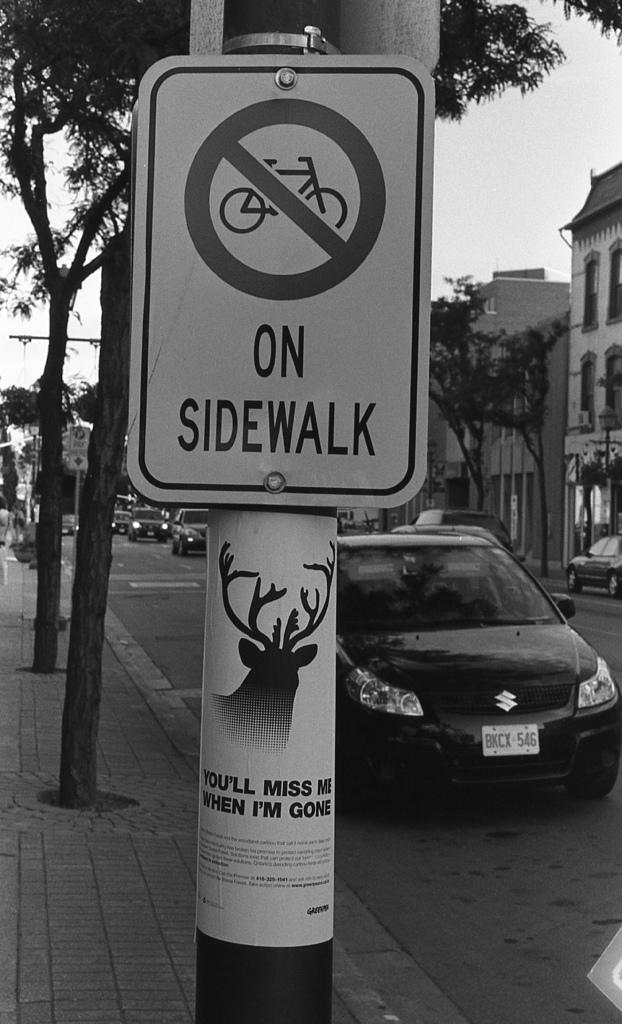What is the main object in the center of the image? There is a sign board in the center of the image. What can be seen in the distance behind the sign board? There are buildings and trees in the background of the image. What is the surface that vehicles are traveling on in the image? There is a road in the image. What is moving along the road in the image? There are vehicles on the road. What type of print can be seen on the bat in the image? There is no bat present in the image. How does the sign board pull the vehicles towards it in the image? The sign board does not pull the vehicles towards it; it is stationary and the vehicles are moving independently. 